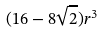<formula> <loc_0><loc_0><loc_500><loc_500>( 1 6 - 8 \sqrt { 2 } ) r ^ { 3 }</formula> 